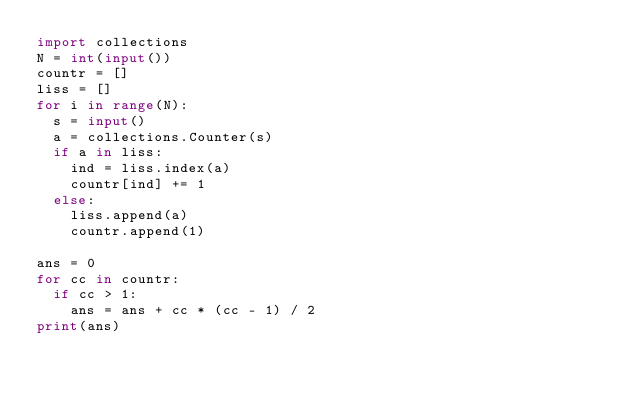Convert code to text. <code><loc_0><loc_0><loc_500><loc_500><_Python_>import collections
N = int(input())
countr = []
liss = []
for i in range(N):
  s = input()
  a = collections.Counter(s)
  if a in liss:
    ind = liss.index(a)
    countr[ind] += 1
  else:
    liss.append(a)
    countr.append(1)

ans = 0
for cc in countr:
  if cc > 1:
    ans = ans + cc * (cc - 1) / 2
print(ans)
</code> 